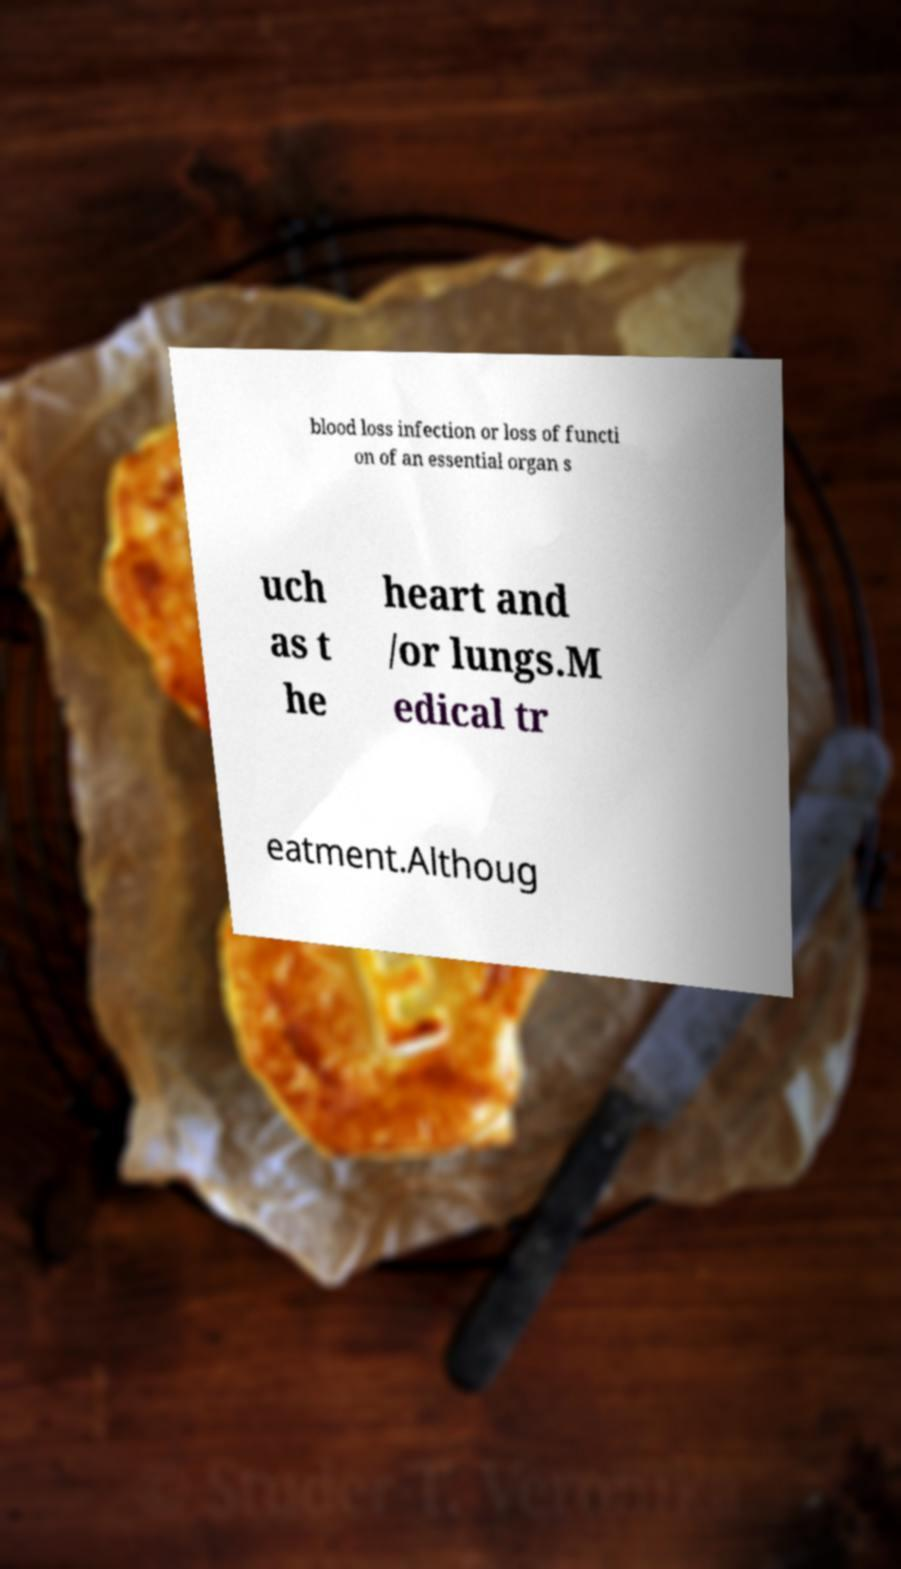Could you assist in decoding the text presented in this image and type it out clearly? blood loss infection or loss of functi on of an essential organ s uch as t he heart and /or lungs.M edical tr eatment.Althoug 